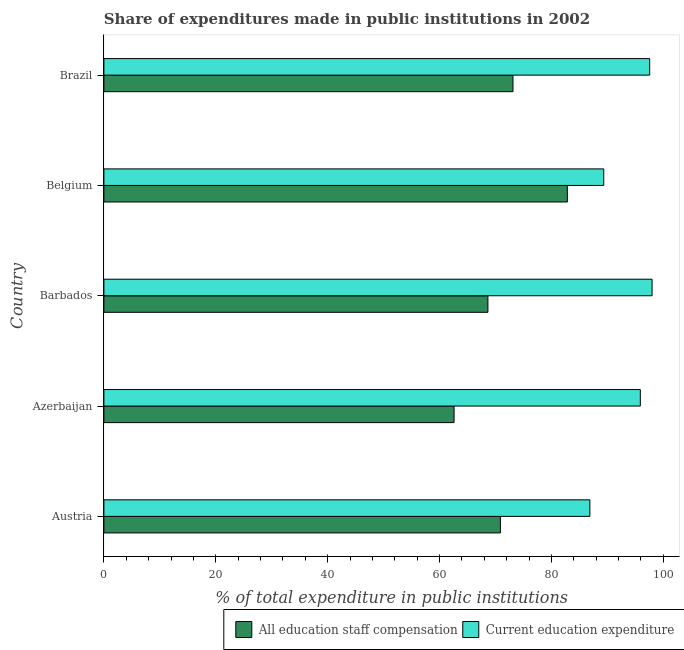How many groups of bars are there?
Offer a very short reply. 5. What is the expenditure in education in Barbados?
Offer a very short reply. 97.98. Across all countries, what is the maximum expenditure in staff compensation?
Your answer should be compact. 82.83. Across all countries, what is the minimum expenditure in education?
Make the answer very short. 86.86. In which country was the expenditure in staff compensation maximum?
Your answer should be compact. Belgium. In which country was the expenditure in education minimum?
Ensure brevity in your answer.  Austria. What is the total expenditure in staff compensation in the graph?
Your answer should be very brief. 358.05. What is the difference between the expenditure in education in Belgium and that in Brazil?
Your answer should be compact. -8.21. What is the difference between the expenditure in education in Brazil and the expenditure in staff compensation in Azerbaijan?
Offer a terse response. 34.96. What is the average expenditure in education per country?
Offer a terse response. 93.52. What is the difference between the expenditure in staff compensation and expenditure in education in Belgium?
Provide a short and direct response. -6.51. In how many countries, is the expenditure in education greater than 16 %?
Keep it short and to the point. 5. What is the ratio of the expenditure in staff compensation in Barbados to that in Belgium?
Offer a very short reply. 0.83. What is the difference between the highest and the second highest expenditure in staff compensation?
Ensure brevity in your answer.  9.71. What is the difference between the highest and the lowest expenditure in education?
Provide a succinct answer. 11.12. In how many countries, is the expenditure in education greater than the average expenditure in education taken over all countries?
Offer a very short reply. 3. Is the sum of the expenditure in education in Austria and Belgium greater than the maximum expenditure in staff compensation across all countries?
Keep it short and to the point. Yes. What does the 1st bar from the top in Austria represents?
Your answer should be very brief. Current education expenditure. What does the 2nd bar from the bottom in Brazil represents?
Offer a very short reply. Current education expenditure. Are all the bars in the graph horizontal?
Ensure brevity in your answer.  Yes. How many countries are there in the graph?
Keep it short and to the point. 5. Does the graph contain grids?
Give a very brief answer. No. Where does the legend appear in the graph?
Give a very brief answer. Bottom right. How many legend labels are there?
Keep it short and to the point. 2. How are the legend labels stacked?
Make the answer very short. Horizontal. What is the title of the graph?
Keep it short and to the point. Share of expenditures made in public institutions in 2002. What is the label or title of the X-axis?
Keep it short and to the point. % of total expenditure in public institutions. What is the label or title of the Y-axis?
Ensure brevity in your answer.  Country. What is the % of total expenditure in public institutions of All education staff compensation in Austria?
Your response must be concise. 70.87. What is the % of total expenditure in public institutions in Current education expenditure in Austria?
Your answer should be compact. 86.86. What is the % of total expenditure in public institutions of All education staff compensation in Azerbaijan?
Offer a very short reply. 62.59. What is the % of total expenditure in public institutions in Current education expenditure in Azerbaijan?
Keep it short and to the point. 95.88. What is the % of total expenditure in public institutions of All education staff compensation in Barbados?
Ensure brevity in your answer.  68.64. What is the % of total expenditure in public institutions in Current education expenditure in Barbados?
Keep it short and to the point. 97.98. What is the % of total expenditure in public institutions of All education staff compensation in Belgium?
Your answer should be very brief. 82.83. What is the % of total expenditure in public institutions of Current education expenditure in Belgium?
Ensure brevity in your answer.  89.34. What is the % of total expenditure in public institutions of All education staff compensation in Brazil?
Offer a terse response. 73.12. What is the % of total expenditure in public institutions in Current education expenditure in Brazil?
Provide a succinct answer. 97.56. Across all countries, what is the maximum % of total expenditure in public institutions in All education staff compensation?
Make the answer very short. 82.83. Across all countries, what is the maximum % of total expenditure in public institutions of Current education expenditure?
Ensure brevity in your answer.  97.98. Across all countries, what is the minimum % of total expenditure in public institutions in All education staff compensation?
Your response must be concise. 62.59. Across all countries, what is the minimum % of total expenditure in public institutions of Current education expenditure?
Provide a short and direct response. 86.86. What is the total % of total expenditure in public institutions of All education staff compensation in the graph?
Provide a succinct answer. 358.05. What is the total % of total expenditure in public institutions of Current education expenditure in the graph?
Make the answer very short. 467.62. What is the difference between the % of total expenditure in public institutions in All education staff compensation in Austria and that in Azerbaijan?
Give a very brief answer. 8.28. What is the difference between the % of total expenditure in public institutions in Current education expenditure in Austria and that in Azerbaijan?
Your answer should be compact. -9.02. What is the difference between the % of total expenditure in public institutions in All education staff compensation in Austria and that in Barbados?
Your response must be concise. 2.23. What is the difference between the % of total expenditure in public institutions of Current education expenditure in Austria and that in Barbados?
Provide a short and direct response. -11.12. What is the difference between the % of total expenditure in public institutions in All education staff compensation in Austria and that in Belgium?
Provide a short and direct response. -11.96. What is the difference between the % of total expenditure in public institutions in Current education expenditure in Austria and that in Belgium?
Keep it short and to the point. -2.48. What is the difference between the % of total expenditure in public institutions of All education staff compensation in Austria and that in Brazil?
Offer a terse response. -2.25. What is the difference between the % of total expenditure in public institutions of Current education expenditure in Austria and that in Brazil?
Provide a succinct answer. -10.7. What is the difference between the % of total expenditure in public institutions in All education staff compensation in Azerbaijan and that in Barbados?
Provide a succinct answer. -6.05. What is the difference between the % of total expenditure in public institutions of Current education expenditure in Azerbaijan and that in Barbados?
Your answer should be very brief. -2.1. What is the difference between the % of total expenditure in public institutions of All education staff compensation in Azerbaijan and that in Belgium?
Provide a short and direct response. -20.24. What is the difference between the % of total expenditure in public institutions in Current education expenditure in Azerbaijan and that in Belgium?
Your response must be concise. 6.53. What is the difference between the % of total expenditure in public institutions of All education staff compensation in Azerbaijan and that in Brazil?
Provide a short and direct response. -10.53. What is the difference between the % of total expenditure in public institutions in Current education expenditure in Azerbaijan and that in Brazil?
Provide a succinct answer. -1.68. What is the difference between the % of total expenditure in public institutions in All education staff compensation in Barbados and that in Belgium?
Offer a very short reply. -14.2. What is the difference between the % of total expenditure in public institutions of Current education expenditure in Barbados and that in Belgium?
Make the answer very short. 8.64. What is the difference between the % of total expenditure in public institutions of All education staff compensation in Barbados and that in Brazil?
Your answer should be very brief. -4.48. What is the difference between the % of total expenditure in public institutions of Current education expenditure in Barbados and that in Brazil?
Offer a very short reply. 0.43. What is the difference between the % of total expenditure in public institutions of All education staff compensation in Belgium and that in Brazil?
Offer a terse response. 9.72. What is the difference between the % of total expenditure in public institutions in Current education expenditure in Belgium and that in Brazil?
Your answer should be compact. -8.21. What is the difference between the % of total expenditure in public institutions in All education staff compensation in Austria and the % of total expenditure in public institutions in Current education expenditure in Azerbaijan?
Make the answer very short. -25.01. What is the difference between the % of total expenditure in public institutions of All education staff compensation in Austria and the % of total expenditure in public institutions of Current education expenditure in Barbados?
Your answer should be very brief. -27.11. What is the difference between the % of total expenditure in public institutions in All education staff compensation in Austria and the % of total expenditure in public institutions in Current education expenditure in Belgium?
Your response must be concise. -18.47. What is the difference between the % of total expenditure in public institutions of All education staff compensation in Austria and the % of total expenditure in public institutions of Current education expenditure in Brazil?
Provide a short and direct response. -26.69. What is the difference between the % of total expenditure in public institutions in All education staff compensation in Azerbaijan and the % of total expenditure in public institutions in Current education expenditure in Barbados?
Offer a very short reply. -35.39. What is the difference between the % of total expenditure in public institutions in All education staff compensation in Azerbaijan and the % of total expenditure in public institutions in Current education expenditure in Belgium?
Offer a very short reply. -26.75. What is the difference between the % of total expenditure in public institutions in All education staff compensation in Azerbaijan and the % of total expenditure in public institutions in Current education expenditure in Brazil?
Your answer should be compact. -34.96. What is the difference between the % of total expenditure in public institutions of All education staff compensation in Barbados and the % of total expenditure in public institutions of Current education expenditure in Belgium?
Offer a terse response. -20.71. What is the difference between the % of total expenditure in public institutions of All education staff compensation in Barbados and the % of total expenditure in public institutions of Current education expenditure in Brazil?
Offer a very short reply. -28.92. What is the difference between the % of total expenditure in public institutions in All education staff compensation in Belgium and the % of total expenditure in public institutions in Current education expenditure in Brazil?
Your answer should be very brief. -14.72. What is the average % of total expenditure in public institutions in All education staff compensation per country?
Give a very brief answer. 71.61. What is the average % of total expenditure in public institutions of Current education expenditure per country?
Make the answer very short. 93.52. What is the difference between the % of total expenditure in public institutions in All education staff compensation and % of total expenditure in public institutions in Current education expenditure in Austria?
Provide a short and direct response. -15.99. What is the difference between the % of total expenditure in public institutions in All education staff compensation and % of total expenditure in public institutions in Current education expenditure in Azerbaijan?
Your answer should be compact. -33.29. What is the difference between the % of total expenditure in public institutions of All education staff compensation and % of total expenditure in public institutions of Current education expenditure in Barbados?
Offer a terse response. -29.34. What is the difference between the % of total expenditure in public institutions of All education staff compensation and % of total expenditure in public institutions of Current education expenditure in Belgium?
Keep it short and to the point. -6.51. What is the difference between the % of total expenditure in public institutions in All education staff compensation and % of total expenditure in public institutions in Current education expenditure in Brazil?
Your answer should be compact. -24.44. What is the ratio of the % of total expenditure in public institutions in All education staff compensation in Austria to that in Azerbaijan?
Make the answer very short. 1.13. What is the ratio of the % of total expenditure in public institutions in Current education expenditure in Austria to that in Azerbaijan?
Your answer should be very brief. 0.91. What is the ratio of the % of total expenditure in public institutions in All education staff compensation in Austria to that in Barbados?
Provide a short and direct response. 1.03. What is the ratio of the % of total expenditure in public institutions of Current education expenditure in Austria to that in Barbados?
Make the answer very short. 0.89. What is the ratio of the % of total expenditure in public institutions in All education staff compensation in Austria to that in Belgium?
Provide a succinct answer. 0.86. What is the ratio of the % of total expenditure in public institutions of Current education expenditure in Austria to that in Belgium?
Your answer should be very brief. 0.97. What is the ratio of the % of total expenditure in public institutions in All education staff compensation in Austria to that in Brazil?
Offer a very short reply. 0.97. What is the ratio of the % of total expenditure in public institutions in Current education expenditure in Austria to that in Brazil?
Your response must be concise. 0.89. What is the ratio of the % of total expenditure in public institutions in All education staff compensation in Azerbaijan to that in Barbados?
Offer a very short reply. 0.91. What is the ratio of the % of total expenditure in public institutions in Current education expenditure in Azerbaijan to that in Barbados?
Offer a terse response. 0.98. What is the ratio of the % of total expenditure in public institutions of All education staff compensation in Azerbaijan to that in Belgium?
Provide a succinct answer. 0.76. What is the ratio of the % of total expenditure in public institutions of Current education expenditure in Azerbaijan to that in Belgium?
Give a very brief answer. 1.07. What is the ratio of the % of total expenditure in public institutions in All education staff compensation in Azerbaijan to that in Brazil?
Offer a terse response. 0.86. What is the ratio of the % of total expenditure in public institutions of Current education expenditure in Azerbaijan to that in Brazil?
Offer a terse response. 0.98. What is the ratio of the % of total expenditure in public institutions of All education staff compensation in Barbados to that in Belgium?
Your response must be concise. 0.83. What is the ratio of the % of total expenditure in public institutions in Current education expenditure in Barbados to that in Belgium?
Your answer should be compact. 1.1. What is the ratio of the % of total expenditure in public institutions of All education staff compensation in Barbados to that in Brazil?
Provide a succinct answer. 0.94. What is the ratio of the % of total expenditure in public institutions in All education staff compensation in Belgium to that in Brazil?
Ensure brevity in your answer.  1.13. What is the ratio of the % of total expenditure in public institutions in Current education expenditure in Belgium to that in Brazil?
Your answer should be compact. 0.92. What is the difference between the highest and the second highest % of total expenditure in public institutions of All education staff compensation?
Your answer should be very brief. 9.72. What is the difference between the highest and the second highest % of total expenditure in public institutions in Current education expenditure?
Provide a short and direct response. 0.43. What is the difference between the highest and the lowest % of total expenditure in public institutions in All education staff compensation?
Your answer should be compact. 20.24. What is the difference between the highest and the lowest % of total expenditure in public institutions of Current education expenditure?
Your response must be concise. 11.12. 